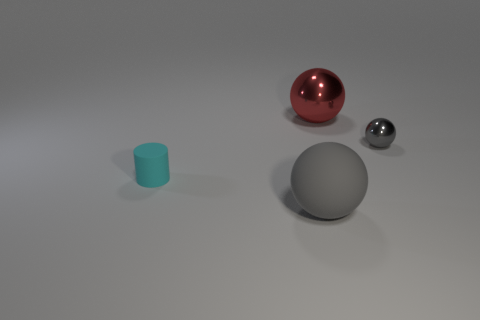There is a big ball that is the same color as the small shiny ball; what is it made of?
Make the answer very short. Rubber. The object that is the same material as the small cylinder is what color?
Offer a very short reply. Gray. There is a shiny object that is on the left side of the tiny object behind the cyan matte cylinder; what is its color?
Offer a terse response. Red. Are there any metal things that have the same color as the large rubber object?
Your response must be concise. Yes. What is the shape of the red shiny object that is the same size as the gray rubber sphere?
Keep it short and to the point. Sphere. What number of large gray things are to the left of the ball that is right of the red metallic thing?
Your response must be concise. 1. Does the big matte object have the same color as the small sphere?
Ensure brevity in your answer.  Yes. How many other objects are the same material as the cyan cylinder?
Provide a succinct answer. 1. What is the shape of the gray object on the right side of the gray thing that is on the left side of the tiny gray metallic ball?
Keep it short and to the point. Sphere. There is a metallic ball that is behind the small gray ball; what is its size?
Provide a short and direct response. Large. 